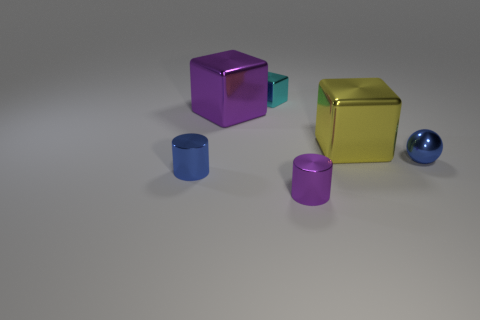Add 2 yellow metallic objects. How many objects exist? 8 Subtract all cylinders. How many objects are left? 4 Subtract 0 cyan spheres. How many objects are left? 6 Subtract all tiny green matte cubes. Subtract all blue cylinders. How many objects are left? 5 Add 2 tiny purple cylinders. How many tiny purple cylinders are left? 3 Add 5 metal blocks. How many metal blocks exist? 8 